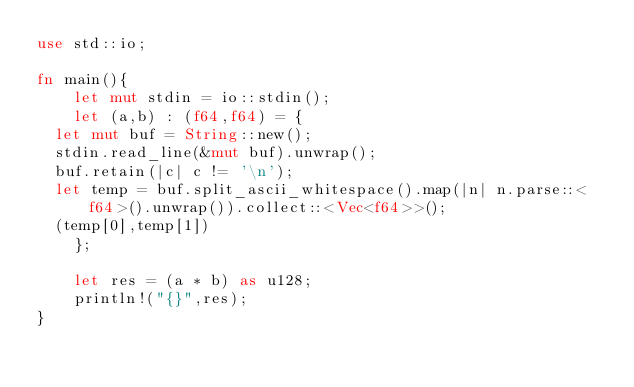Convert code to text. <code><loc_0><loc_0><loc_500><loc_500><_Rust_>use std::io;

fn main(){
    let mut stdin = io::stdin();
    let (a,b) : (f64,f64) = {
	let mut buf = String::new();
	stdin.read_line(&mut buf).unwrap();
	buf.retain(|c| c != '\n');
	let temp = buf.split_ascii_whitespace().map(|n| n.parse::<f64>().unwrap()).collect::<Vec<f64>>();
	(temp[0],temp[1])
    };

    let res = (a * b) as u128;
    println!("{}",res);
}
</code> 